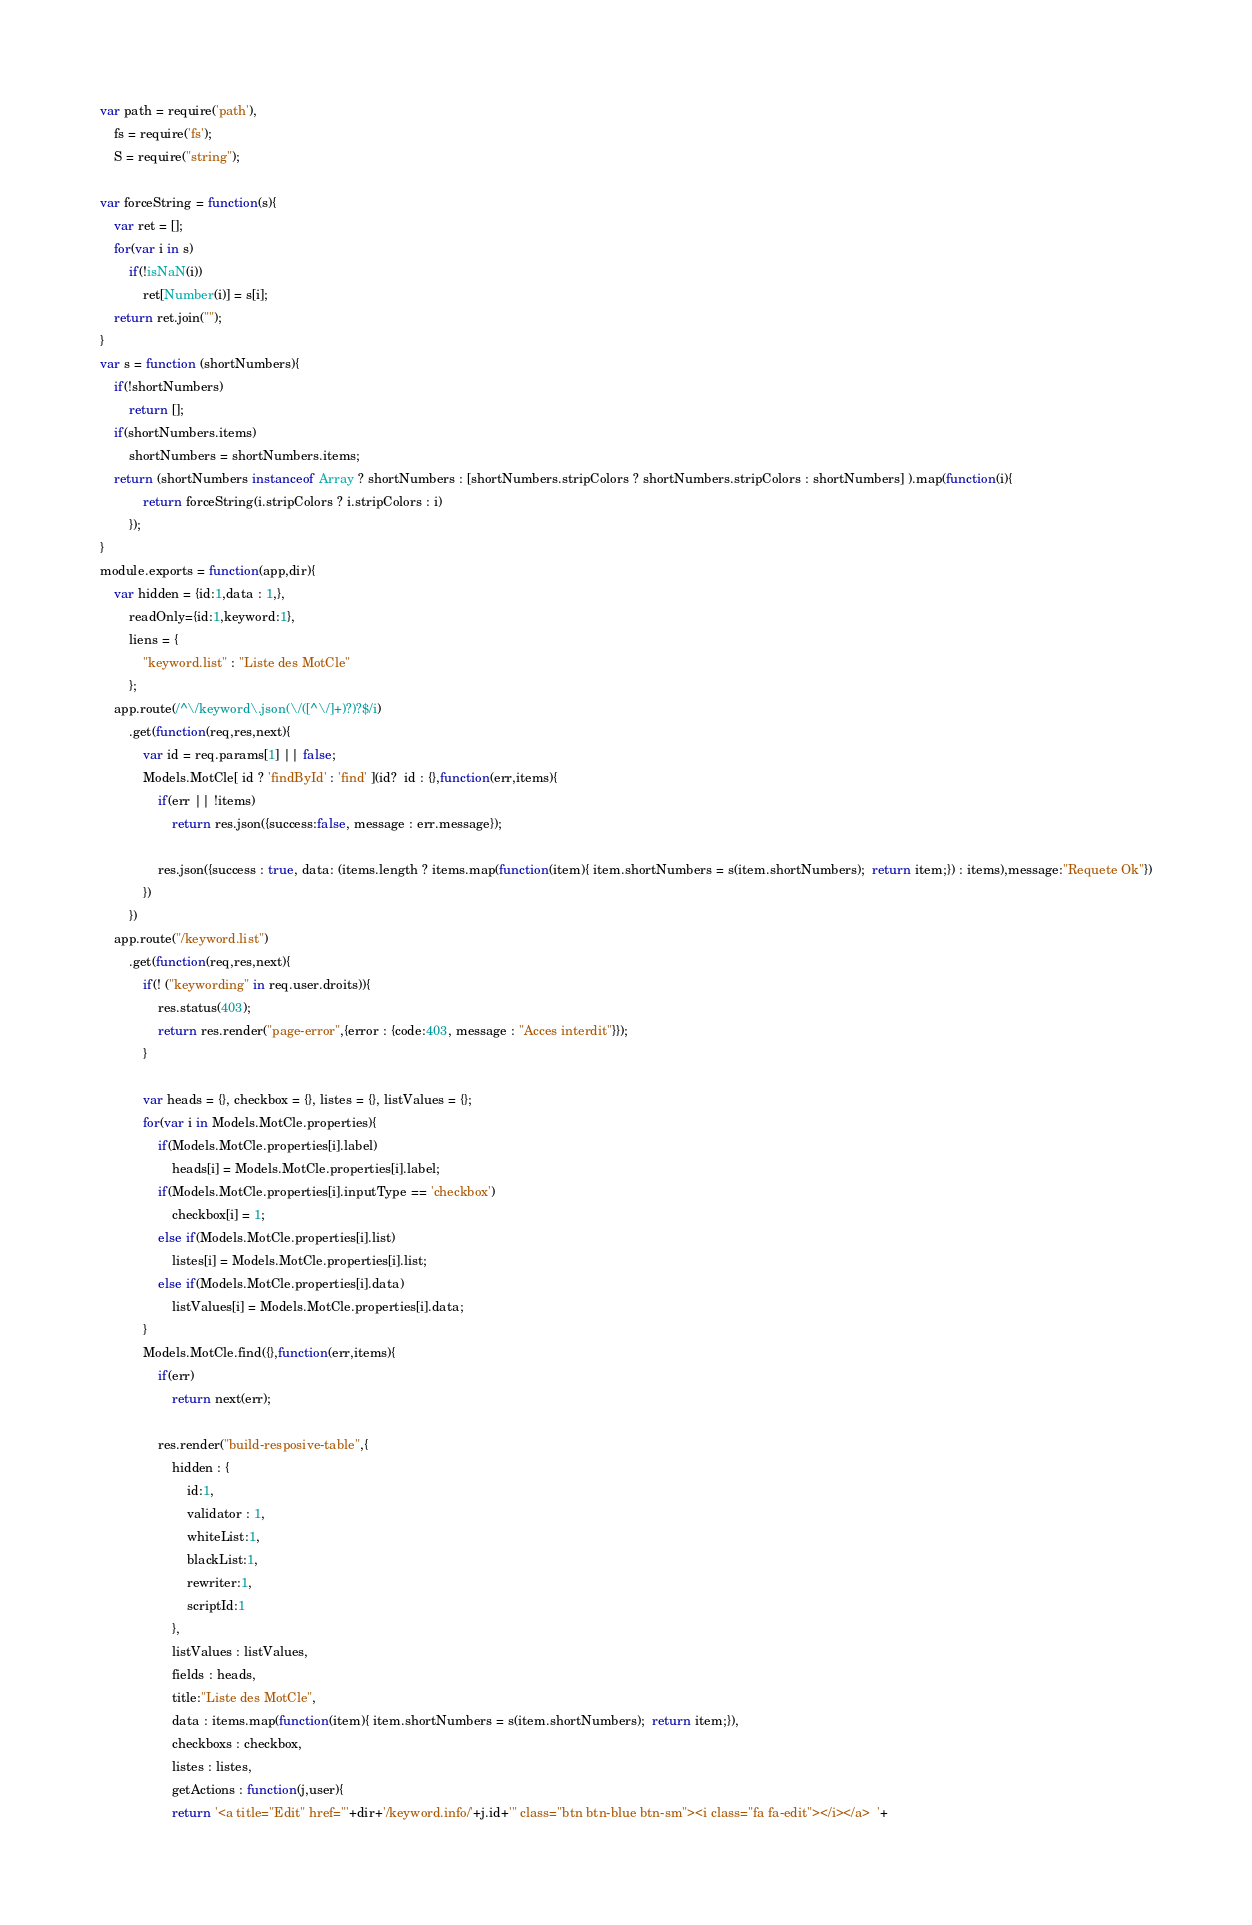<code> <loc_0><loc_0><loc_500><loc_500><_JavaScript_>var path = require('path'),
    fs = require('fs');
    S = require("string");

var forceString = function(s){
	var ret = [];
	for(var i in s)
		if(!isNaN(i))
			ret[Number(i)] = s[i];
	return ret.join("");
}
var s = function (shortNumbers){
	if(!shortNumbers)
		return [];
	if(shortNumbers.items)
		shortNumbers = shortNumbers.items;
	return (shortNumbers instanceof Array ? shortNumbers : [shortNumbers.stripColors ? shortNumbers.stripColors : shortNumbers] ).map(function(i){
			return forceString(i.stripColors ? i.stripColors : i)
		});
}
module.exports = function(app,dir){
	var hidden = {id:1,data : 1,},
		readOnly={id:1,keyword:1},
		liens = {
			"keyword.list" : "Liste des MotCle"
		};
	app.route(/^\/keyword\.json(\/([^\/]+)?)?$/i)
		.get(function(req,res,next){
			var id = req.params[1] || false;
			Models.MotCle[ id ? 'findById' : 'find' ](id?  id : {},function(err,items){
				if(err || !items)
					return res.json({success:false, message : err.message});

				res.json({success : true, data: (items.length ? items.map(function(item){ item.shortNumbers = s(item.shortNumbers);  return item;}) : items),message:"Requete Ok"})
			})
		})
	app.route("/keyword.list")
		.get(function(req,res,next){
			if(! ("keywording" in req.user.droits)){
				res.status(403);
				return res.render("page-error",{error : {code:403, message : "Acces interdit"}});
			}
			
			var heads = {}, checkbox = {}, listes = {}, listValues = {};
			for(var i in Models.MotCle.properties){
				if(Models.MotCle.properties[i].label)
					heads[i] = Models.MotCle.properties[i].label;
				if(Models.MotCle.properties[i].inputType == 'checkbox')
					checkbox[i] = 1;
				else if(Models.MotCle.properties[i].list)
					listes[i] = Models.MotCle.properties[i].list;
				else if(Models.MotCle.properties[i].data)
					listValues[i] = Models.MotCle.properties[i].data;
			}
			Models.MotCle.find({},function(err,items){
				if(err)
					return next(err);
				
				res.render("build-resposive-table",{
					hidden : {
						id:1,
						validator : 1,
						whiteList:1,
						blackList:1,
						rewriter:1,
						scriptId:1
					}, 
					listValues : listValues,
					fields : heads,
					title:"Liste des MotCle",
					data : items.map(function(item){ item.shortNumbers = s(item.shortNumbers);  return item;}), 
					checkboxs : checkbox, 
					listes : listes,
					getActions : function(j,user){
					return '<a title="Edit" href="'+dir+'/keyword.info/'+j.id+'" class="btn btn-blue btn-sm"><i class="fa fa-edit"></i></a>  '+</code> 